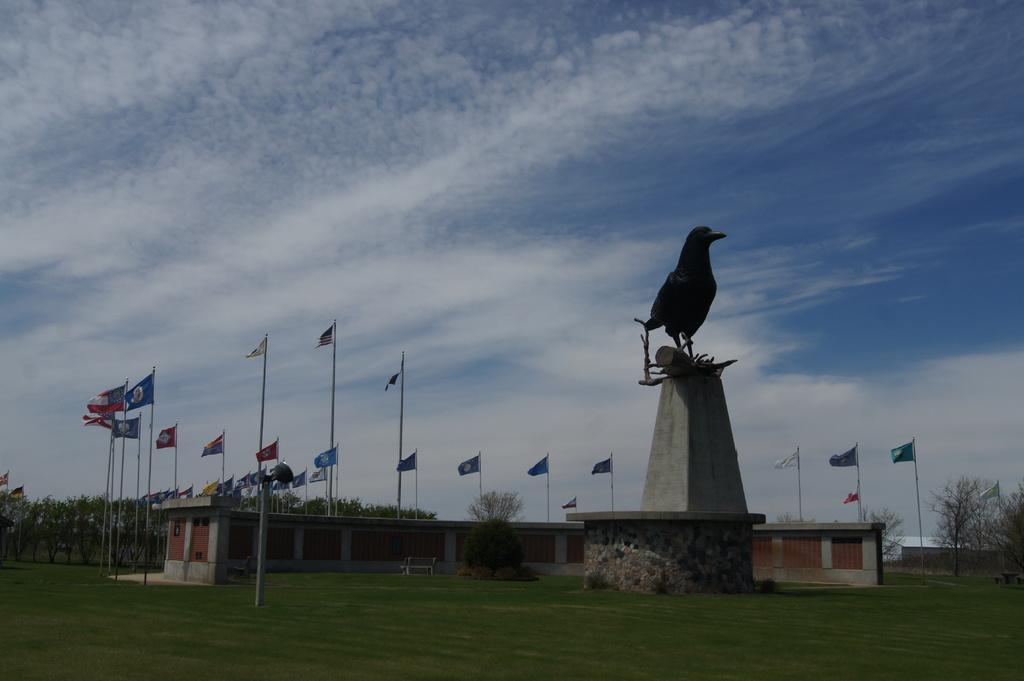Please provide a concise description of this image. As we can see in the image there is grass, buildings, flags, a bird statue and trees. On the top there is sky and clouds. 